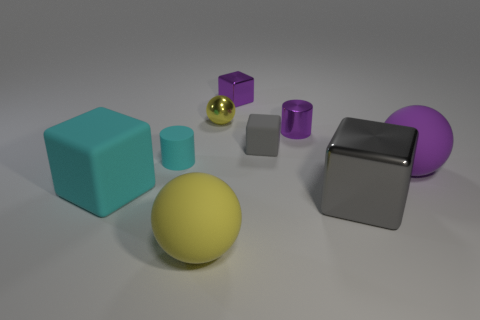Subtract all brown blocks. Subtract all gray spheres. How many blocks are left? 4 Add 1 tiny brown metal things. How many objects exist? 10 Subtract all cylinders. How many objects are left? 7 Add 1 tiny matte blocks. How many tiny matte blocks exist? 2 Subtract 0 brown spheres. How many objects are left? 9 Subtract all tiny spheres. Subtract all large cyan objects. How many objects are left? 7 Add 4 small gray cubes. How many small gray cubes are left? 5 